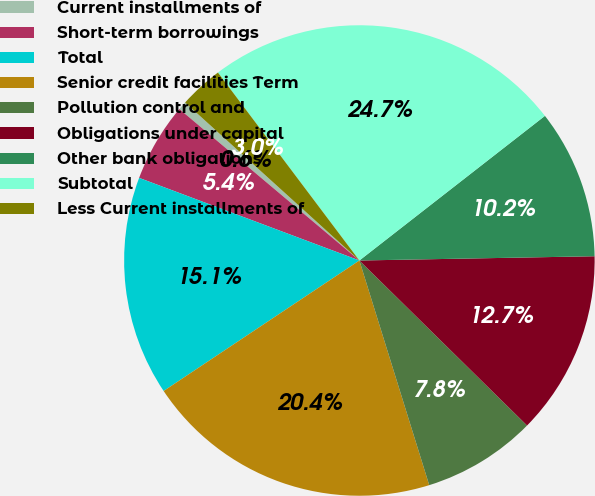Convert chart to OTSL. <chart><loc_0><loc_0><loc_500><loc_500><pie_chart><fcel>Current installments of<fcel>Short-term borrowings<fcel>Total<fcel>Senior credit facilities Term<fcel>Pollution control and<fcel>Obligations under capital<fcel>Other bank obligations<fcel>Subtotal<fcel>Less Current installments of<nl><fcel>0.59%<fcel>5.42%<fcel>15.07%<fcel>20.44%<fcel>7.83%<fcel>12.66%<fcel>10.25%<fcel>24.73%<fcel>3.01%<nl></chart> 